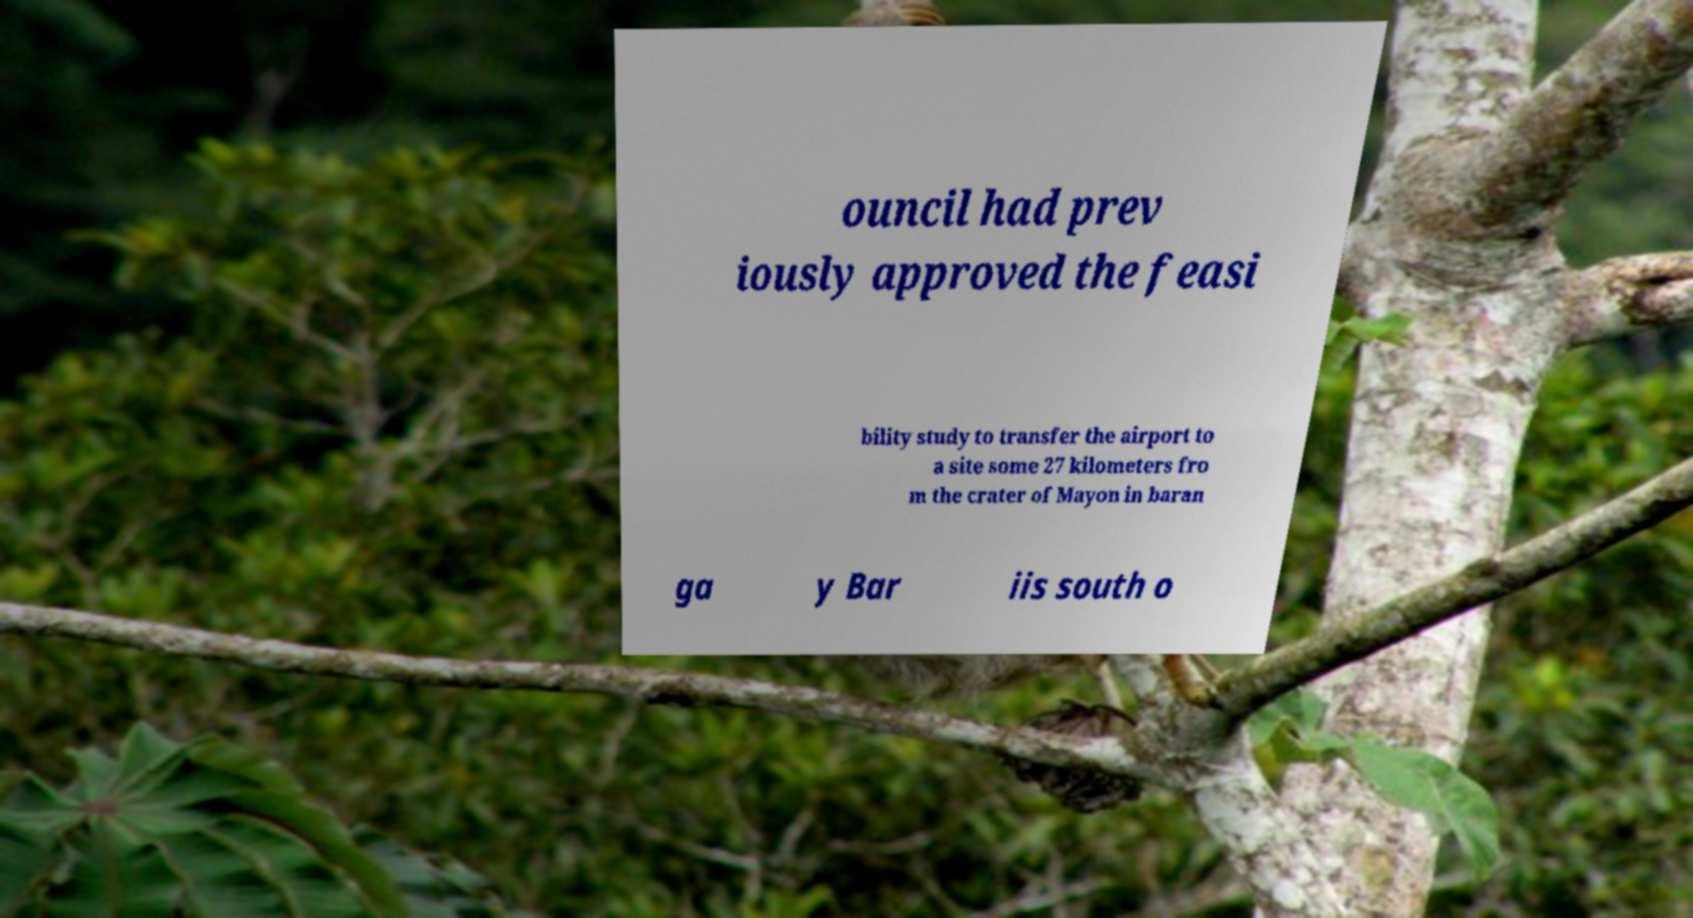For documentation purposes, I need the text within this image transcribed. Could you provide that? ouncil had prev iously approved the feasi bility study to transfer the airport to a site some 27 kilometers fro m the crater of Mayon in baran ga y Bar iis south o 